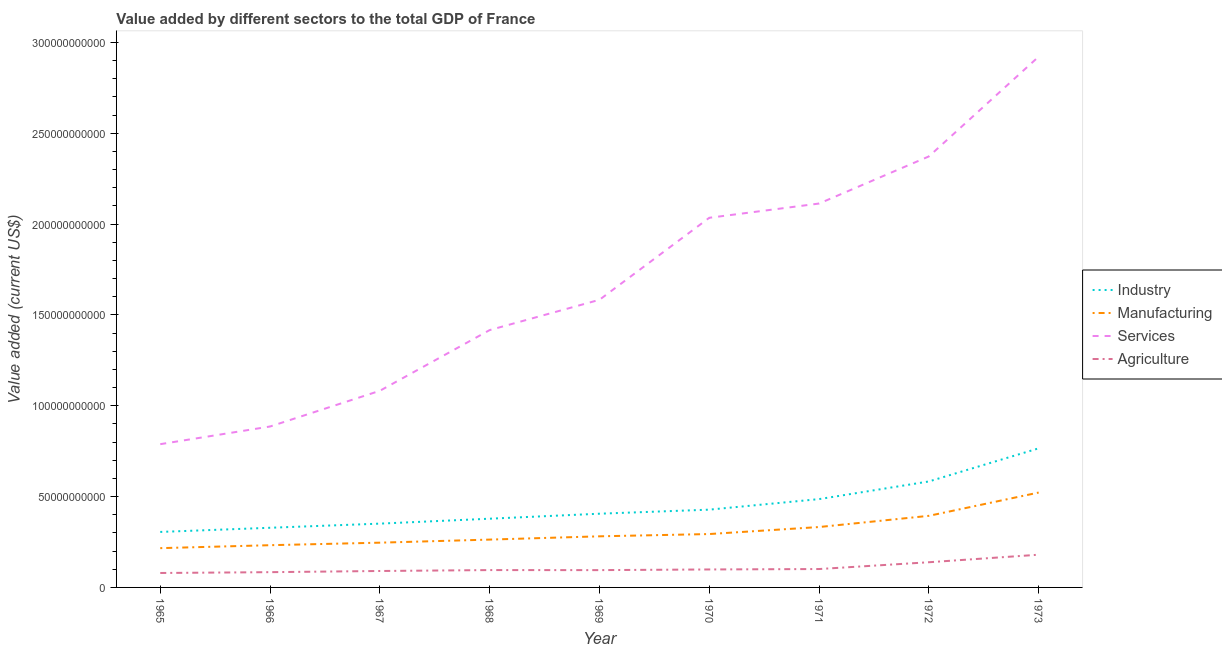Does the line corresponding to value added by industrial sector intersect with the line corresponding to value added by services sector?
Ensure brevity in your answer.  No. Is the number of lines equal to the number of legend labels?
Ensure brevity in your answer.  Yes. What is the value added by manufacturing sector in 1965?
Offer a very short reply. 2.16e+1. Across all years, what is the maximum value added by services sector?
Offer a terse response. 2.92e+11. Across all years, what is the minimum value added by services sector?
Make the answer very short. 7.88e+1. In which year was the value added by services sector maximum?
Ensure brevity in your answer.  1973. In which year was the value added by industrial sector minimum?
Provide a short and direct response. 1965. What is the total value added by services sector in the graph?
Your answer should be compact. 1.52e+12. What is the difference between the value added by industrial sector in 1971 and that in 1972?
Offer a terse response. -9.72e+09. What is the difference between the value added by manufacturing sector in 1972 and the value added by services sector in 1968?
Give a very brief answer. -1.02e+11. What is the average value added by agricultural sector per year?
Your answer should be very brief. 1.07e+1. In the year 1967, what is the difference between the value added by services sector and value added by manufacturing sector?
Your answer should be very brief. 8.36e+1. What is the ratio of the value added by services sector in 1969 to that in 1970?
Your answer should be compact. 0.78. Is the value added by services sector in 1965 less than that in 1971?
Provide a succinct answer. Yes. Is the difference between the value added by services sector in 1965 and 1972 greater than the difference between the value added by agricultural sector in 1965 and 1972?
Make the answer very short. No. What is the difference between the highest and the second highest value added by agricultural sector?
Keep it short and to the point. 4.15e+09. What is the difference between the highest and the lowest value added by agricultural sector?
Provide a succinct answer. 1.01e+1. In how many years, is the value added by services sector greater than the average value added by services sector taken over all years?
Your response must be concise. 4. Is it the case that in every year, the sum of the value added by services sector and value added by manufacturing sector is greater than the sum of value added by industrial sector and value added by agricultural sector?
Give a very brief answer. Yes. Does the value added by industrial sector monotonically increase over the years?
Offer a terse response. Yes. Is the value added by manufacturing sector strictly greater than the value added by agricultural sector over the years?
Provide a succinct answer. Yes. How many lines are there?
Ensure brevity in your answer.  4. Are the values on the major ticks of Y-axis written in scientific E-notation?
Offer a very short reply. No. Does the graph contain any zero values?
Provide a succinct answer. No. Does the graph contain grids?
Your answer should be compact. No. What is the title of the graph?
Your answer should be very brief. Value added by different sectors to the total GDP of France. What is the label or title of the X-axis?
Your answer should be very brief. Year. What is the label or title of the Y-axis?
Your response must be concise. Value added (current US$). What is the Value added (current US$) of Industry in 1965?
Give a very brief answer. 3.05e+1. What is the Value added (current US$) of Manufacturing in 1965?
Make the answer very short. 2.16e+1. What is the Value added (current US$) of Services in 1965?
Keep it short and to the point. 7.88e+1. What is the Value added (current US$) of Agriculture in 1965?
Provide a succinct answer. 7.95e+09. What is the Value added (current US$) in Industry in 1966?
Offer a terse response. 3.28e+1. What is the Value added (current US$) in Manufacturing in 1966?
Offer a very short reply. 2.32e+1. What is the Value added (current US$) in Services in 1966?
Provide a succinct answer. 8.86e+1. What is the Value added (current US$) of Agriculture in 1966?
Ensure brevity in your answer.  8.40e+09. What is the Value added (current US$) in Industry in 1967?
Offer a very short reply. 3.51e+1. What is the Value added (current US$) in Manufacturing in 1967?
Your answer should be compact. 2.46e+1. What is the Value added (current US$) in Services in 1967?
Ensure brevity in your answer.  1.08e+11. What is the Value added (current US$) of Agriculture in 1967?
Provide a succinct answer. 9.05e+09. What is the Value added (current US$) of Industry in 1968?
Keep it short and to the point. 3.78e+1. What is the Value added (current US$) of Manufacturing in 1968?
Make the answer very short. 2.63e+1. What is the Value added (current US$) of Services in 1968?
Your response must be concise. 1.42e+11. What is the Value added (current US$) of Agriculture in 1968?
Offer a terse response. 9.55e+09. What is the Value added (current US$) in Industry in 1969?
Keep it short and to the point. 4.06e+1. What is the Value added (current US$) in Manufacturing in 1969?
Provide a short and direct response. 2.81e+1. What is the Value added (current US$) of Services in 1969?
Provide a succinct answer. 1.58e+11. What is the Value added (current US$) in Agriculture in 1969?
Your response must be concise. 9.52e+09. What is the Value added (current US$) in Industry in 1970?
Offer a terse response. 4.28e+1. What is the Value added (current US$) of Manufacturing in 1970?
Provide a short and direct response. 2.94e+1. What is the Value added (current US$) of Services in 1970?
Give a very brief answer. 2.03e+11. What is the Value added (current US$) in Agriculture in 1970?
Your response must be concise. 9.89e+09. What is the Value added (current US$) in Industry in 1971?
Your answer should be compact. 4.86e+1. What is the Value added (current US$) of Manufacturing in 1971?
Provide a succinct answer. 3.32e+1. What is the Value added (current US$) in Services in 1971?
Ensure brevity in your answer.  2.11e+11. What is the Value added (current US$) in Agriculture in 1971?
Ensure brevity in your answer.  1.01e+1. What is the Value added (current US$) of Industry in 1972?
Provide a short and direct response. 5.83e+1. What is the Value added (current US$) in Manufacturing in 1972?
Your answer should be compact. 3.94e+1. What is the Value added (current US$) of Services in 1972?
Keep it short and to the point. 2.37e+11. What is the Value added (current US$) in Agriculture in 1972?
Offer a very short reply. 1.39e+1. What is the Value added (current US$) of Industry in 1973?
Keep it short and to the point. 7.65e+1. What is the Value added (current US$) of Manufacturing in 1973?
Offer a terse response. 5.22e+1. What is the Value added (current US$) of Services in 1973?
Your response must be concise. 2.92e+11. What is the Value added (current US$) of Agriculture in 1973?
Your answer should be compact. 1.80e+1. Across all years, what is the maximum Value added (current US$) in Industry?
Keep it short and to the point. 7.65e+1. Across all years, what is the maximum Value added (current US$) of Manufacturing?
Give a very brief answer. 5.22e+1. Across all years, what is the maximum Value added (current US$) in Services?
Your response must be concise. 2.92e+11. Across all years, what is the maximum Value added (current US$) of Agriculture?
Your response must be concise. 1.80e+1. Across all years, what is the minimum Value added (current US$) of Industry?
Offer a terse response. 3.05e+1. Across all years, what is the minimum Value added (current US$) in Manufacturing?
Offer a very short reply. 2.16e+1. Across all years, what is the minimum Value added (current US$) of Services?
Provide a short and direct response. 7.88e+1. Across all years, what is the minimum Value added (current US$) in Agriculture?
Make the answer very short. 7.95e+09. What is the total Value added (current US$) in Industry in the graph?
Keep it short and to the point. 4.03e+11. What is the total Value added (current US$) in Manufacturing in the graph?
Offer a terse response. 2.78e+11. What is the total Value added (current US$) in Services in the graph?
Offer a terse response. 1.52e+12. What is the total Value added (current US$) of Agriculture in the graph?
Give a very brief answer. 9.63e+1. What is the difference between the Value added (current US$) in Industry in 1965 and that in 1966?
Keep it short and to the point. -2.29e+09. What is the difference between the Value added (current US$) in Manufacturing in 1965 and that in 1966?
Your response must be concise. -1.62e+09. What is the difference between the Value added (current US$) in Services in 1965 and that in 1966?
Your answer should be very brief. -9.73e+09. What is the difference between the Value added (current US$) of Agriculture in 1965 and that in 1966?
Your response must be concise. -4.53e+08. What is the difference between the Value added (current US$) of Industry in 1965 and that in 1967?
Ensure brevity in your answer.  -4.57e+09. What is the difference between the Value added (current US$) in Manufacturing in 1965 and that in 1967?
Make the answer very short. -3.01e+09. What is the difference between the Value added (current US$) of Services in 1965 and that in 1967?
Provide a short and direct response. -2.94e+1. What is the difference between the Value added (current US$) of Agriculture in 1965 and that in 1967?
Ensure brevity in your answer.  -1.10e+09. What is the difference between the Value added (current US$) of Industry in 1965 and that in 1968?
Provide a succinct answer. -7.28e+09. What is the difference between the Value added (current US$) of Manufacturing in 1965 and that in 1968?
Provide a short and direct response. -4.71e+09. What is the difference between the Value added (current US$) in Services in 1965 and that in 1968?
Offer a very short reply. -6.28e+1. What is the difference between the Value added (current US$) in Agriculture in 1965 and that in 1968?
Your answer should be very brief. -1.60e+09. What is the difference between the Value added (current US$) in Industry in 1965 and that in 1969?
Your answer should be compact. -1.00e+1. What is the difference between the Value added (current US$) of Manufacturing in 1965 and that in 1969?
Offer a very short reply. -6.51e+09. What is the difference between the Value added (current US$) of Services in 1965 and that in 1969?
Ensure brevity in your answer.  -7.95e+1. What is the difference between the Value added (current US$) in Agriculture in 1965 and that in 1969?
Your answer should be compact. -1.58e+09. What is the difference between the Value added (current US$) in Industry in 1965 and that in 1970?
Make the answer very short. -1.23e+1. What is the difference between the Value added (current US$) in Manufacturing in 1965 and that in 1970?
Offer a very short reply. -7.76e+09. What is the difference between the Value added (current US$) of Services in 1965 and that in 1970?
Provide a short and direct response. -1.25e+11. What is the difference between the Value added (current US$) in Agriculture in 1965 and that in 1970?
Ensure brevity in your answer.  -1.94e+09. What is the difference between the Value added (current US$) in Industry in 1965 and that in 1971?
Offer a very short reply. -1.81e+1. What is the difference between the Value added (current US$) in Manufacturing in 1965 and that in 1971?
Your answer should be very brief. -1.16e+1. What is the difference between the Value added (current US$) in Services in 1965 and that in 1971?
Offer a terse response. -1.32e+11. What is the difference between the Value added (current US$) in Agriculture in 1965 and that in 1971?
Provide a short and direct response. -2.17e+09. What is the difference between the Value added (current US$) of Industry in 1965 and that in 1972?
Offer a terse response. -2.78e+1. What is the difference between the Value added (current US$) in Manufacturing in 1965 and that in 1972?
Your answer should be very brief. -1.78e+1. What is the difference between the Value added (current US$) of Services in 1965 and that in 1972?
Provide a short and direct response. -1.58e+11. What is the difference between the Value added (current US$) in Agriculture in 1965 and that in 1972?
Give a very brief answer. -5.91e+09. What is the difference between the Value added (current US$) in Industry in 1965 and that in 1973?
Offer a terse response. -4.60e+1. What is the difference between the Value added (current US$) in Manufacturing in 1965 and that in 1973?
Provide a succinct answer. -3.06e+1. What is the difference between the Value added (current US$) in Services in 1965 and that in 1973?
Your answer should be compact. -2.13e+11. What is the difference between the Value added (current US$) in Agriculture in 1965 and that in 1973?
Your answer should be very brief. -1.01e+1. What is the difference between the Value added (current US$) of Industry in 1966 and that in 1967?
Your response must be concise. -2.28e+09. What is the difference between the Value added (current US$) of Manufacturing in 1966 and that in 1967?
Your answer should be very brief. -1.39e+09. What is the difference between the Value added (current US$) in Services in 1966 and that in 1967?
Offer a terse response. -1.97e+1. What is the difference between the Value added (current US$) of Agriculture in 1966 and that in 1967?
Provide a short and direct response. -6.46e+08. What is the difference between the Value added (current US$) of Industry in 1966 and that in 1968?
Your response must be concise. -4.99e+09. What is the difference between the Value added (current US$) of Manufacturing in 1966 and that in 1968?
Your response must be concise. -3.08e+09. What is the difference between the Value added (current US$) of Services in 1966 and that in 1968?
Provide a succinct answer. -5.31e+1. What is the difference between the Value added (current US$) in Agriculture in 1966 and that in 1968?
Ensure brevity in your answer.  -1.15e+09. What is the difference between the Value added (current US$) of Industry in 1966 and that in 1969?
Your answer should be very brief. -7.74e+09. What is the difference between the Value added (current US$) in Manufacturing in 1966 and that in 1969?
Your response must be concise. -4.88e+09. What is the difference between the Value added (current US$) in Services in 1966 and that in 1969?
Your response must be concise. -6.97e+1. What is the difference between the Value added (current US$) of Agriculture in 1966 and that in 1969?
Keep it short and to the point. -1.12e+09. What is the difference between the Value added (current US$) of Industry in 1966 and that in 1970?
Your response must be concise. -9.97e+09. What is the difference between the Value added (current US$) of Manufacturing in 1966 and that in 1970?
Your response must be concise. -6.14e+09. What is the difference between the Value added (current US$) of Services in 1966 and that in 1970?
Ensure brevity in your answer.  -1.15e+11. What is the difference between the Value added (current US$) of Agriculture in 1966 and that in 1970?
Provide a succinct answer. -1.49e+09. What is the difference between the Value added (current US$) in Industry in 1966 and that in 1971?
Provide a succinct answer. -1.58e+1. What is the difference between the Value added (current US$) of Manufacturing in 1966 and that in 1971?
Your answer should be compact. -1.00e+1. What is the difference between the Value added (current US$) of Services in 1966 and that in 1971?
Provide a succinct answer. -1.23e+11. What is the difference between the Value added (current US$) of Agriculture in 1966 and that in 1971?
Offer a terse response. -1.72e+09. What is the difference between the Value added (current US$) of Industry in 1966 and that in 1972?
Offer a terse response. -2.55e+1. What is the difference between the Value added (current US$) of Manufacturing in 1966 and that in 1972?
Offer a very short reply. -1.62e+1. What is the difference between the Value added (current US$) in Services in 1966 and that in 1972?
Keep it short and to the point. -1.49e+11. What is the difference between the Value added (current US$) of Agriculture in 1966 and that in 1972?
Provide a short and direct response. -5.46e+09. What is the difference between the Value added (current US$) of Industry in 1966 and that in 1973?
Make the answer very short. -4.37e+1. What is the difference between the Value added (current US$) of Manufacturing in 1966 and that in 1973?
Offer a very short reply. -2.90e+1. What is the difference between the Value added (current US$) of Services in 1966 and that in 1973?
Give a very brief answer. -2.04e+11. What is the difference between the Value added (current US$) in Agriculture in 1966 and that in 1973?
Ensure brevity in your answer.  -9.61e+09. What is the difference between the Value added (current US$) in Industry in 1967 and that in 1968?
Offer a very short reply. -2.71e+09. What is the difference between the Value added (current US$) of Manufacturing in 1967 and that in 1968?
Provide a succinct answer. -1.69e+09. What is the difference between the Value added (current US$) in Services in 1967 and that in 1968?
Your answer should be compact. -3.34e+1. What is the difference between the Value added (current US$) of Agriculture in 1967 and that in 1968?
Provide a succinct answer. -5.04e+08. What is the difference between the Value added (current US$) of Industry in 1967 and that in 1969?
Your answer should be compact. -5.46e+09. What is the difference between the Value added (current US$) of Manufacturing in 1967 and that in 1969?
Provide a short and direct response. -3.49e+09. What is the difference between the Value added (current US$) in Services in 1967 and that in 1969?
Your answer should be very brief. -5.01e+1. What is the difference between the Value added (current US$) of Agriculture in 1967 and that in 1969?
Your answer should be compact. -4.78e+08. What is the difference between the Value added (current US$) of Industry in 1967 and that in 1970?
Ensure brevity in your answer.  -7.70e+09. What is the difference between the Value added (current US$) in Manufacturing in 1967 and that in 1970?
Make the answer very short. -4.75e+09. What is the difference between the Value added (current US$) of Services in 1967 and that in 1970?
Ensure brevity in your answer.  -9.52e+1. What is the difference between the Value added (current US$) in Agriculture in 1967 and that in 1970?
Offer a very short reply. -8.44e+08. What is the difference between the Value added (current US$) in Industry in 1967 and that in 1971?
Provide a short and direct response. -1.35e+1. What is the difference between the Value added (current US$) of Manufacturing in 1967 and that in 1971?
Your response must be concise. -8.61e+09. What is the difference between the Value added (current US$) of Services in 1967 and that in 1971?
Give a very brief answer. -1.03e+11. What is the difference between the Value added (current US$) in Agriculture in 1967 and that in 1971?
Make the answer very short. -1.08e+09. What is the difference between the Value added (current US$) in Industry in 1967 and that in 1972?
Your answer should be very brief. -2.32e+1. What is the difference between the Value added (current US$) in Manufacturing in 1967 and that in 1972?
Make the answer very short. -1.48e+1. What is the difference between the Value added (current US$) of Services in 1967 and that in 1972?
Offer a very short reply. -1.29e+11. What is the difference between the Value added (current US$) of Agriculture in 1967 and that in 1972?
Your answer should be compact. -4.81e+09. What is the difference between the Value added (current US$) in Industry in 1967 and that in 1973?
Give a very brief answer. -4.14e+1. What is the difference between the Value added (current US$) in Manufacturing in 1967 and that in 1973?
Your answer should be compact. -2.76e+1. What is the difference between the Value added (current US$) in Services in 1967 and that in 1973?
Offer a terse response. -1.84e+11. What is the difference between the Value added (current US$) in Agriculture in 1967 and that in 1973?
Give a very brief answer. -8.96e+09. What is the difference between the Value added (current US$) in Industry in 1968 and that in 1969?
Keep it short and to the point. -2.75e+09. What is the difference between the Value added (current US$) in Manufacturing in 1968 and that in 1969?
Offer a very short reply. -1.80e+09. What is the difference between the Value added (current US$) of Services in 1968 and that in 1969?
Provide a short and direct response. -1.67e+1. What is the difference between the Value added (current US$) in Agriculture in 1968 and that in 1969?
Offer a terse response. 2.57e+07. What is the difference between the Value added (current US$) of Industry in 1968 and that in 1970?
Offer a terse response. -4.98e+09. What is the difference between the Value added (current US$) in Manufacturing in 1968 and that in 1970?
Provide a succinct answer. -3.05e+09. What is the difference between the Value added (current US$) of Services in 1968 and that in 1970?
Provide a short and direct response. -6.18e+1. What is the difference between the Value added (current US$) in Agriculture in 1968 and that in 1970?
Your answer should be compact. -3.40e+08. What is the difference between the Value added (current US$) in Industry in 1968 and that in 1971?
Make the answer very short. -1.08e+1. What is the difference between the Value added (current US$) in Manufacturing in 1968 and that in 1971?
Provide a short and direct response. -6.91e+09. What is the difference between the Value added (current US$) in Services in 1968 and that in 1971?
Keep it short and to the point. -6.96e+1. What is the difference between the Value added (current US$) of Agriculture in 1968 and that in 1971?
Give a very brief answer. -5.72e+08. What is the difference between the Value added (current US$) of Industry in 1968 and that in 1972?
Provide a short and direct response. -2.05e+1. What is the difference between the Value added (current US$) of Manufacturing in 1968 and that in 1972?
Your answer should be compact. -1.31e+1. What is the difference between the Value added (current US$) of Services in 1968 and that in 1972?
Offer a very short reply. -9.56e+1. What is the difference between the Value added (current US$) in Agriculture in 1968 and that in 1972?
Your response must be concise. -4.31e+09. What is the difference between the Value added (current US$) of Industry in 1968 and that in 1973?
Your answer should be very brief. -3.87e+1. What is the difference between the Value added (current US$) of Manufacturing in 1968 and that in 1973?
Keep it short and to the point. -2.59e+1. What is the difference between the Value added (current US$) of Services in 1968 and that in 1973?
Keep it short and to the point. -1.50e+11. What is the difference between the Value added (current US$) in Agriculture in 1968 and that in 1973?
Offer a very short reply. -8.46e+09. What is the difference between the Value added (current US$) in Industry in 1969 and that in 1970?
Provide a succinct answer. -2.23e+09. What is the difference between the Value added (current US$) in Manufacturing in 1969 and that in 1970?
Make the answer very short. -1.25e+09. What is the difference between the Value added (current US$) in Services in 1969 and that in 1970?
Give a very brief answer. -4.51e+1. What is the difference between the Value added (current US$) in Agriculture in 1969 and that in 1970?
Provide a succinct answer. -3.66e+08. What is the difference between the Value added (current US$) of Industry in 1969 and that in 1971?
Your answer should be very brief. -8.03e+09. What is the difference between the Value added (current US$) of Manufacturing in 1969 and that in 1971?
Give a very brief answer. -5.11e+09. What is the difference between the Value added (current US$) of Services in 1969 and that in 1971?
Provide a short and direct response. -5.30e+1. What is the difference between the Value added (current US$) in Agriculture in 1969 and that in 1971?
Offer a terse response. -5.97e+08. What is the difference between the Value added (current US$) of Industry in 1969 and that in 1972?
Provide a succinct answer. -1.77e+1. What is the difference between the Value added (current US$) of Manufacturing in 1969 and that in 1972?
Ensure brevity in your answer.  -1.13e+1. What is the difference between the Value added (current US$) of Services in 1969 and that in 1972?
Make the answer very short. -7.89e+1. What is the difference between the Value added (current US$) of Agriculture in 1969 and that in 1972?
Offer a very short reply. -4.34e+09. What is the difference between the Value added (current US$) in Industry in 1969 and that in 1973?
Keep it short and to the point. -3.60e+1. What is the difference between the Value added (current US$) of Manufacturing in 1969 and that in 1973?
Give a very brief answer. -2.41e+1. What is the difference between the Value added (current US$) in Services in 1969 and that in 1973?
Provide a succinct answer. -1.34e+11. What is the difference between the Value added (current US$) of Agriculture in 1969 and that in 1973?
Provide a short and direct response. -8.48e+09. What is the difference between the Value added (current US$) of Industry in 1970 and that in 1971?
Provide a succinct answer. -5.80e+09. What is the difference between the Value added (current US$) of Manufacturing in 1970 and that in 1971?
Give a very brief answer. -3.86e+09. What is the difference between the Value added (current US$) of Services in 1970 and that in 1971?
Offer a terse response. -7.84e+09. What is the difference between the Value added (current US$) of Agriculture in 1970 and that in 1971?
Your answer should be very brief. -2.32e+08. What is the difference between the Value added (current US$) in Industry in 1970 and that in 1972?
Offer a very short reply. -1.55e+1. What is the difference between the Value added (current US$) in Manufacturing in 1970 and that in 1972?
Your answer should be compact. -1.00e+1. What is the difference between the Value added (current US$) in Services in 1970 and that in 1972?
Make the answer very short. -3.38e+1. What is the difference between the Value added (current US$) of Agriculture in 1970 and that in 1972?
Ensure brevity in your answer.  -3.97e+09. What is the difference between the Value added (current US$) in Industry in 1970 and that in 1973?
Keep it short and to the point. -3.37e+1. What is the difference between the Value added (current US$) of Manufacturing in 1970 and that in 1973?
Ensure brevity in your answer.  -2.28e+1. What is the difference between the Value added (current US$) of Services in 1970 and that in 1973?
Your answer should be very brief. -8.87e+1. What is the difference between the Value added (current US$) in Agriculture in 1970 and that in 1973?
Your response must be concise. -8.12e+09. What is the difference between the Value added (current US$) of Industry in 1971 and that in 1972?
Provide a succinct answer. -9.72e+09. What is the difference between the Value added (current US$) of Manufacturing in 1971 and that in 1972?
Keep it short and to the point. -6.16e+09. What is the difference between the Value added (current US$) of Services in 1971 and that in 1972?
Provide a succinct answer. -2.59e+1. What is the difference between the Value added (current US$) of Agriculture in 1971 and that in 1972?
Your answer should be compact. -3.74e+09. What is the difference between the Value added (current US$) of Industry in 1971 and that in 1973?
Your response must be concise. -2.79e+1. What is the difference between the Value added (current US$) of Manufacturing in 1971 and that in 1973?
Provide a succinct answer. -1.90e+1. What is the difference between the Value added (current US$) in Services in 1971 and that in 1973?
Offer a very short reply. -8.08e+1. What is the difference between the Value added (current US$) in Agriculture in 1971 and that in 1973?
Your answer should be compact. -7.89e+09. What is the difference between the Value added (current US$) of Industry in 1972 and that in 1973?
Provide a succinct answer. -1.82e+1. What is the difference between the Value added (current US$) of Manufacturing in 1972 and that in 1973?
Offer a very short reply. -1.28e+1. What is the difference between the Value added (current US$) in Services in 1972 and that in 1973?
Ensure brevity in your answer.  -5.49e+1. What is the difference between the Value added (current US$) in Agriculture in 1972 and that in 1973?
Ensure brevity in your answer.  -4.15e+09. What is the difference between the Value added (current US$) of Industry in 1965 and the Value added (current US$) of Manufacturing in 1966?
Your answer should be compact. 7.30e+09. What is the difference between the Value added (current US$) in Industry in 1965 and the Value added (current US$) in Services in 1966?
Make the answer very short. -5.80e+1. What is the difference between the Value added (current US$) in Industry in 1965 and the Value added (current US$) in Agriculture in 1966?
Make the answer very short. 2.21e+1. What is the difference between the Value added (current US$) of Manufacturing in 1965 and the Value added (current US$) of Services in 1966?
Make the answer very short. -6.69e+1. What is the difference between the Value added (current US$) of Manufacturing in 1965 and the Value added (current US$) of Agriculture in 1966?
Make the answer very short. 1.32e+1. What is the difference between the Value added (current US$) of Services in 1965 and the Value added (current US$) of Agriculture in 1966?
Provide a succinct answer. 7.04e+1. What is the difference between the Value added (current US$) in Industry in 1965 and the Value added (current US$) in Manufacturing in 1967?
Offer a terse response. 5.91e+09. What is the difference between the Value added (current US$) of Industry in 1965 and the Value added (current US$) of Services in 1967?
Offer a terse response. -7.77e+1. What is the difference between the Value added (current US$) of Industry in 1965 and the Value added (current US$) of Agriculture in 1967?
Keep it short and to the point. 2.15e+1. What is the difference between the Value added (current US$) of Manufacturing in 1965 and the Value added (current US$) of Services in 1967?
Your answer should be very brief. -8.66e+1. What is the difference between the Value added (current US$) in Manufacturing in 1965 and the Value added (current US$) in Agriculture in 1967?
Ensure brevity in your answer.  1.26e+1. What is the difference between the Value added (current US$) in Services in 1965 and the Value added (current US$) in Agriculture in 1967?
Offer a very short reply. 6.98e+1. What is the difference between the Value added (current US$) of Industry in 1965 and the Value added (current US$) of Manufacturing in 1968?
Ensure brevity in your answer.  4.21e+09. What is the difference between the Value added (current US$) of Industry in 1965 and the Value added (current US$) of Services in 1968?
Provide a succinct answer. -1.11e+11. What is the difference between the Value added (current US$) in Industry in 1965 and the Value added (current US$) in Agriculture in 1968?
Provide a short and direct response. 2.10e+1. What is the difference between the Value added (current US$) in Manufacturing in 1965 and the Value added (current US$) in Services in 1968?
Give a very brief answer. -1.20e+11. What is the difference between the Value added (current US$) of Manufacturing in 1965 and the Value added (current US$) of Agriculture in 1968?
Give a very brief answer. 1.21e+1. What is the difference between the Value added (current US$) of Services in 1965 and the Value added (current US$) of Agriculture in 1968?
Keep it short and to the point. 6.93e+1. What is the difference between the Value added (current US$) in Industry in 1965 and the Value added (current US$) in Manufacturing in 1969?
Provide a short and direct response. 2.41e+09. What is the difference between the Value added (current US$) of Industry in 1965 and the Value added (current US$) of Services in 1969?
Offer a very short reply. -1.28e+11. What is the difference between the Value added (current US$) of Industry in 1965 and the Value added (current US$) of Agriculture in 1969?
Provide a succinct answer. 2.10e+1. What is the difference between the Value added (current US$) in Manufacturing in 1965 and the Value added (current US$) in Services in 1969?
Offer a very short reply. -1.37e+11. What is the difference between the Value added (current US$) in Manufacturing in 1965 and the Value added (current US$) in Agriculture in 1969?
Keep it short and to the point. 1.21e+1. What is the difference between the Value added (current US$) in Services in 1965 and the Value added (current US$) in Agriculture in 1969?
Make the answer very short. 6.93e+1. What is the difference between the Value added (current US$) of Industry in 1965 and the Value added (current US$) of Manufacturing in 1970?
Keep it short and to the point. 1.16e+09. What is the difference between the Value added (current US$) of Industry in 1965 and the Value added (current US$) of Services in 1970?
Ensure brevity in your answer.  -1.73e+11. What is the difference between the Value added (current US$) of Industry in 1965 and the Value added (current US$) of Agriculture in 1970?
Offer a very short reply. 2.07e+1. What is the difference between the Value added (current US$) in Manufacturing in 1965 and the Value added (current US$) in Services in 1970?
Offer a terse response. -1.82e+11. What is the difference between the Value added (current US$) in Manufacturing in 1965 and the Value added (current US$) in Agriculture in 1970?
Offer a terse response. 1.17e+1. What is the difference between the Value added (current US$) of Services in 1965 and the Value added (current US$) of Agriculture in 1970?
Offer a terse response. 6.90e+1. What is the difference between the Value added (current US$) in Industry in 1965 and the Value added (current US$) in Manufacturing in 1971?
Offer a terse response. -2.70e+09. What is the difference between the Value added (current US$) of Industry in 1965 and the Value added (current US$) of Services in 1971?
Provide a succinct answer. -1.81e+11. What is the difference between the Value added (current US$) of Industry in 1965 and the Value added (current US$) of Agriculture in 1971?
Make the answer very short. 2.04e+1. What is the difference between the Value added (current US$) of Manufacturing in 1965 and the Value added (current US$) of Services in 1971?
Give a very brief answer. -1.90e+11. What is the difference between the Value added (current US$) in Manufacturing in 1965 and the Value added (current US$) in Agriculture in 1971?
Ensure brevity in your answer.  1.15e+1. What is the difference between the Value added (current US$) of Services in 1965 and the Value added (current US$) of Agriculture in 1971?
Ensure brevity in your answer.  6.87e+1. What is the difference between the Value added (current US$) of Industry in 1965 and the Value added (current US$) of Manufacturing in 1972?
Give a very brief answer. -8.86e+09. What is the difference between the Value added (current US$) of Industry in 1965 and the Value added (current US$) of Services in 1972?
Your answer should be very brief. -2.07e+11. What is the difference between the Value added (current US$) in Industry in 1965 and the Value added (current US$) in Agriculture in 1972?
Your response must be concise. 1.67e+1. What is the difference between the Value added (current US$) in Manufacturing in 1965 and the Value added (current US$) in Services in 1972?
Provide a succinct answer. -2.16e+11. What is the difference between the Value added (current US$) of Manufacturing in 1965 and the Value added (current US$) of Agriculture in 1972?
Your response must be concise. 7.76e+09. What is the difference between the Value added (current US$) of Services in 1965 and the Value added (current US$) of Agriculture in 1972?
Give a very brief answer. 6.50e+1. What is the difference between the Value added (current US$) in Industry in 1965 and the Value added (current US$) in Manufacturing in 1973?
Offer a terse response. -2.17e+1. What is the difference between the Value added (current US$) of Industry in 1965 and the Value added (current US$) of Services in 1973?
Offer a terse response. -2.62e+11. What is the difference between the Value added (current US$) of Industry in 1965 and the Value added (current US$) of Agriculture in 1973?
Your answer should be compact. 1.25e+1. What is the difference between the Value added (current US$) in Manufacturing in 1965 and the Value added (current US$) in Services in 1973?
Provide a short and direct response. -2.71e+11. What is the difference between the Value added (current US$) of Manufacturing in 1965 and the Value added (current US$) of Agriculture in 1973?
Give a very brief answer. 3.61e+09. What is the difference between the Value added (current US$) in Services in 1965 and the Value added (current US$) in Agriculture in 1973?
Your response must be concise. 6.08e+1. What is the difference between the Value added (current US$) of Industry in 1966 and the Value added (current US$) of Manufacturing in 1967?
Offer a terse response. 8.20e+09. What is the difference between the Value added (current US$) in Industry in 1966 and the Value added (current US$) in Services in 1967?
Your answer should be very brief. -7.54e+1. What is the difference between the Value added (current US$) in Industry in 1966 and the Value added (current US$) in Agriculture in 1967?
Your answer should be very brief. 2.38e+1. What is the difference between the Value added (current US$) of Manufacturing in 1966 and the Value added (current US$) of Services in 1967?
Make the answer very short. -8.50e+1. What is the difference between the Value added (current US$) in Manufacturing in 1966 and the Value added (current US$) in Agriculture in 1967?
Keep it short and to the point. 1.42e+1. What is the difference between the Value added (current US$) in Services in 1966 and the Value added (current US$) in Agriculture in 1967?
Provide a succinct answer. 7.95e+1. What is the difference between the Value added (current US$) of Industry in 1966 and the Value added (current US$) of Manufacturing in 1968?
Your answer should be very brief. 6.51e+09. What is the difference between the Value added (current US$) of Industry in 1966 and the Value added (current US$) of Services in 1968?
Offer a terse response. -1.09e+11. What is the difference between the Value added (current US$) in Industry in 1966 and the Value added (current US$) in Agriculture in 1968?
Offer a very short reply. 2.33e+1. What is the difference between the Value added (current US$) in Manufacturing in 1966 and the Value added (current US$) in Services in 1968?
Offer a very short reply. -1.18e+11. What is the difference between the Value added (current US$) in Manufacturing in 1966 and the Value added (current US$) in Agriculture in 1968?
Keep it short and to the point. 1.37e+1. What is the difference between the Value added (current US$) in Services in 1966 and the Value added (current US$) in Agriculture in 1968?
Keep it short and to the point. 7.90e+1. What is the difference between the Value added (current US$) in Industry in 1966 and the Value added (current US$) in Manufacturing in 1969?
Provide a succinct answer. 4.71e+09. What is the difference between the Value added (current US$) of Industry in 1966 and the Value added (current US$) of Services in 1969?
Give a very brief answer. -1.25e+11. What is the difference between the Value added (current US$) of Industry in 1966 and the Value added (current US$) of Agriculture in 1969?
Give a very brief answer. 2.33e+1. What is the difference between the Value added (current US$) in Manufacturing in 1966 and the Value added (current US$) in Services in 1969?
Your answer should be very brief. -1.35e+11. What is the difference between the Value added (current US$) in Manufacturing in 1966 and the Value added (current US$) in Agriculture in 1969?
Keep it short and to the point. 1.37e+1. What is the difference between the Value added (current US$) of Services in 1966 and the Value added (current US$) of Agriculture in 1969?
Provide a succinct answer. 7.90e+1. What is the difference between the Value added (current US$) of Industry in 1966 and the Value added (current US$) of Manufacturing in 1970?
Your response must be concise. 3.46e+09. What is the difference between the Value added (current US$) in Industry in 1966 and the Value added (current US$) in Services in 1970?
Offer a terse response. -1.71e+11. What is the difference between the Value added (current US$) in Industry in 1966 and the Value added (current US$) in Agriculture in 1970?
Provide a short and direct response. 2.29e+1. What is the difference between the Value added (current US$) in Manufacturing in 1966 and the Value added (current US$) in Services in 1970?
Provide a succinct answer. -1.80e+11. What is the difference between the Value added (current US$) in Manufacturing in 1966 and the Value added (current US$) in Agriculture in 1970?
Provide a succinct answer. 1.34e+1. What is the difference between the Value added (current US$) of Services in 1966 and the Value added (current US$) of Agriculture in 1970?
Offer a terse response. 7.87e+1. What is the difference between the Value added (current US$) in Industry in 1966 and the Value added (current US$) in Manufacturing in 1971?
Your answer should be compact. -4.04e+08. What is the difference between the Value added (current US$) of Industry in 1966 and the Value added (current US$) of Services in 1971?
Your answer should be very brief. -1.78e+11. What is the difference between the Value added (current US$) in Industry in 1966 and the Value added (current US$) in Agriculture in 1971?
Make the answer very short. 2.27e+1. What is the difference between the Value added (current US$) in Manufacturing in 1966 and the Value added (current US$) in Services in 1971?
Your response must be concise. -1.88e+11. What is the difference between the Value added (current US$) of Manufacturing in 1966 and the Value added (current US$) of Agriculture in 1971?
Your answer should be very brief. 1.31e+1. What is the difference between the Value added (current US$) of Services in 1966 and the Value added (current US$) of Agriculture in 1971?
Make the answer very short. 7.84e+1. What is the difference between the Value added (current US$) of Industry in 1966 and the Value added (current US$) of Manufacturing in 1972?
Make the answer very short. -6.57e+09. What is the difference between the Value added (current US$) in Industry in 1966 and the Value added (current US$) in Services in 1972?
Provide a short and direct response. -2.04e+11. What is the difference between the Value added (current US$) in Industry in 1966 and the Value added (current US$) in Agriculture in 1972?
Offer a terse response. 1.90e+1. What is the difference between the Value added (current US$) in Manufacturing in 1966 and the Value added (current US$) in Services in 1972?
Provide a short and direct response. -2.14e+11. What is the difference between the Value added (current US$) in Manufacturing in 1966 and the Value added (current US$) in Agriculture in 1972?
Offer a very short reply. 9.38e+09. What is the difference between the Value added (current US$) of Services in 1966 and the Value added (current US$) of Agriculture in 1972?
Provide a short and direct response. 7.47e+1. What is the difference between the Value added (current US$) in Industry in 1966 and the Value added (current US$) in Manufacturing in 1973?
Give a very brief answer. -1.94e+1. What is the difference between the Value added (current US$) of Industry in 1966 and the Value added (current US$) of Services in 1973?
Your answer should be compact. -2.59e+11. What is the difference between the Value added (current US$) in Industry in 1966 and the Value added (current US$) in Agriculture in 1973?
Keep it short and to the point. 1.48e+1. What is the difference between the Value added (current US$) of Manufacturing in 1966 and the Value added (current US$) of Services in 1973?
Your answer should be very brief. -2.69e+11. What is the difference between the Value added (current US$) in Manufacturing in 1966 and the Value added (current US$) in Agriculture in 1973?
Keep it short and to the point. 5.24e+09. What is the difference between the Value added (current US$) in Services in 1966 and the Value added (current US$) in Agriculture in 1973?
Your answer should be compact. 7.06e+1. What is the difference between the Value added (current US$) in Industry in 1967 and the Value added (current US$) in Manufacturing in 1968?
Make the answer very short. 8.79e+09. What is the difference between the Value added (current US$) in Industry in 1967 and the Value added (current US$) in Services in 1968?
Provide a succinct answer. -1.07e+11. What is the difference between the Value added (current US$) in Industry in 1967 and the Value added (current US$) in Agriculture in 1968?
Give a very brief answer. 2.56e+1. What is the difference between the Value added (current US$) in Manufacturing in 1967 and the Value added (current US$) in Services in 1968?
Your answer should be very brief. -1.17e+11. What is the difference between the Value added (current US$) of Manufacturing in 1967 and the Value added (current US$) of Agriculture in 1968?
Your response must be concise. 1.51e+1. What is the difference between the Value added (current US$) of Services in 1967 and the Value added (current US$) of Agriculture in 1968?
Keep it short and to the point. 9.87e+1. What is the difference between the Value added (current US$) of Industry in 1967 and the Value added (current US$) of Manufacturing in 1969?
Make the answer very short. 6.99e+09. What is the difference between the Value added (current US$) of Industry in 1967 and the Value added (current US$) of Services in 1969?
Keep it short and to the point. -1.23e+11. What is the difference between the Value added (current US$) in Industry in 1967 and the Value added (current US$) in Agriculture in 1969?
Your answer should be very brief. 2.56e+1. What is the difference between the Value added (current US$) of Manufacturing in 1967 and the Value added (current US$) of Services in 1969?
Make the answer very short. -1.34e+11. What is the difference between the Value added (current US$) of Manufacturing in 1967 and the Value added (current US$) of Agriculture in 1969?
Provide a succinct answer. 1.51e+1. What is the difference between the Value added (current US$) in Services in 1967 and the Value added (current US$) in Agriculture in 1969?
Keep it short and to the point. 9.87e+1. What is the difference between the Value added (current US$) of Industry in 1967 and the Value added (current US$) of Manufacturing in 1970?
Your response must be concise. 5.73e+09. What is the difference between the Value added (current US$) in Industry in 1967 and the Value added (current US$) in Services in 1970?
Provide a succinct answer. -1.68e+11. What is the difference between the Value added (current US$) of Industry in 1967 and the Value added (current US$) of Agriculture in 1970?
Offer a terse response. 2.52e+1. What is the difference between the Value added (current US$) in Manufacturing in 1967 and the Value added (current US$) in Services in 1970?
Provide a succinct answer. -1.79e+11. What is the difference between the Value added (current US$) of Manufacturing in 1967 and the Value added (current US$) of Agriculture in 1970?
Make the answer very short. 1.47e+1. What is the difference between the Value added (current US$) in Services in 1967 and the Value added (current US$) in Agriculture in 1970?
Make the answer very short. 9.83e+1. What is the difference between the Value added (current US$) of Industry in 1967 and the Value added (current US$) of Manufacturing in 1971?
Ensure brevity in your answer.  1.87e+09. What is the difference between the Value added (current US$) in Industry in 1967 and the Value added (current US$) in Services in 1971?
Offer a terse response. -1.76e+11. What is the difference between the Value added (current US$) of Industry in 1967 and the Value added (current US$) of Agriculture in 1971?
Provide a succinct answer. 2.50e+1. What is the difference between the Value added (current US$) of Manufacturing in 1967 and the Value added (current US$) of Services in 1971?
Provide a succinct answer. -1.87e+11. What is the difference between the Value added (current US$) of Manufacturing in 1967 and the Value added (current US$) of Agriculture in 1971?
Keep it short and to the point. 1.45e+1. What is the difference between the Value added (current US$) in Services in 1967 and the Value added (current US$) in Agriculture in 1971?
Offer a very short reply. 9.81e+1. What is the difference between the Value added (current US$) of Industry in 1967 and the Value added (current US$) of Manufacturing in 1972?
Provide a short and direct response. -4.29e+09. What is the difference between the Value added (current US$) in Industry in 1967 and the Value added (current US$) in Services in 1972?
Your answer should be compact. -2.02e+11. What is the difference between the Value added (current US$) of Industry in 1967 and the Value added (current US$) of Agriculture in 1972?
Keep it short and to the point. 2.13e+1. What is the difference between the Value added (current US$) in Manufacturing in 1967 and the Value added (current US$) in Services in 1972?
Keep it short and to the point. -2.13e+11. What is the difference between the Value added (current US$) in Manufacturing in 1967 and the Value added (current US$) in Agriculture in 1972?
Provide a succinct answer. 1.08e+1. What is the difference between the Value added (current US$) in Services in 1967 and the Value added (current US$) in Agriculture in 1972?
Your response must be concise. 9.44e+1. What is the difference between the Value added (current US$) of Industry in 1967 and the Value added (current US$) of Manufacturing in 1973?
Offer a very short reply. -1.71e+1. What is the difference between the Value added (current US$) of Industry in 1967 and the Value added (current US$) of Services in 1973?
Offer a very short reply. -2.57e+11. What is the difference between the Value added (current US$) in Industry in 1967 and the Value added (current US$) in Agriculture in 1973?
Offer a very short reply. 1.71e+1. What is the difference between the Value added (current US$) in Manufacturing in 1967 and the Value added (current US$) in Services in 1973?
Provide a succinct answer. -2.67e+11. What is the difference between the Value added (current US$) of Manufacturing in 1967 and the Value added (current US$) of Agriculture in 1973?
Offer a very short reply. 6.63e+09. What is the difference between the Value added (current US$) of Services in 1967 and the Value added (current US$) of Agriculture in 1973?
Give a very brief answer. 9.02e+1. What is the difference between the Value added (current US$) in Industry in 1968 and the Value added (current US$) in Manufacturing in 1969?
Offer a terse response. 9.70e+09. What is the difference between the Value added (current US$) of Industry in 1968 and the Value added (current US$) of Services in 1969?
Offer a very short reply. -1.20e+11. What is the difference between the Value added (current US$) of Industry in 1968 and the Value added (current US$) of Agriculture in 1969?
Offer a terse response. 2.83e+1. What is the difference between the Value added (current US$) in Manufacturing in 1968 and the Value added (current US$) in Services in 1969?
Give a very brief answer. -1.32e+11. What is the difference between the Value added (current US$) of Manufacturing in 1968 and the Value added (current US$) of Agriculture in 1969?
Offer a terse response. 1.68e+1. What is the difference between the Value added (current US$) of Services in 1968 and the Value added (current US$) of Agriculture in 1969?
Your answer should be very brief. 1.32e+11. What is the difference between the Value added (current US$) of Industry in 1968 and the Value added (current US$) of Manufacturing in 1970?
Make the answer very short. 8.45e+09. What is the difference between the Value added (current US$) of Industry in 1968 and the Value added (current US$) of Services in 1970?
Make the answer very short. -1.66e+11. What is the difference between the Value added (current US$) of Industry in 1968 and the Value added (current US$) of Agriculture in 1970?
Provide a succinct answer. 2.79e+1. What is the difference between the Value added (current US$) in Manufacturing in 1968 and the Value added (current US$) in Services in 1970?
Provide a short and direct response. -1.77e+11. What is the difference between the Value added (current US$) in Manufacturing in 1968 and the Value added (current US$) in Agriculture in 1970?
Give a very brief answer. 1.64e+1. What is the difference between the Value added (current US$) of Services in 1968 and the Value added (current US$) of Agriculture in 1970?
Ensure brevity in your answer.  1.32e+11. What is the difference between the Value added (current US$) of Industry in 1968 and the Value added (current US$) of Manufacturing in 1971?
Your answer should be compact. 4.58e+09. What is the difference between the Value added (current US$) of Industry in 1968 and the Value added (current US$) of Services in 1971?
Ensure brevity in your answer.  -1.73e+11. What is the difference between the Value added (current US$) in Industry in 1968 and the Value added (current US$) in Agriculture in 1971?
Make the answer very short. 2.77e+1. What is the difference between the Value added (current US$) of Manufacturing in 1968 and the Value added (current US$) of Services in 1971?
Your answer should be compact. -1.85e+11. What is the difference between the Value added (current US$) of Manufacturing in 1968 and the Value added (current US$) of Agriculture in 1971?
Your response must be concise. 1.62e+1. What is the difference between the Value added (current US$) of Services in 1968 and the Value added (current US$) of Agriculture in 1971?
Offer a terse response. 1.32e+11. What is the difference between the Value added (current US$) in Industry in 1968 and the Value added (current US$) in Manufacturing in 1972?
Offer a terse response. -1.58e+09. What is the difference between the Value added (current US$) in Industry in 1968 and the Value added (current US$) in Services in 1972?
Give a very brief answer. -1.99e+11. What is the difference between the Value added (current US$) of Industry in 1968 and the Value added (current US$) of Agriculture in 1972?
Offer a very short reply. 2.40e+1. What is the difference between the Value added (current US$) of Manufacturing in 1968 and the Value added (current US$) of Services in 1972?
Your answer should be compact. -2.11e+11. What is the difference between the Value added (current US$) of Manufacturing in 1968 and the Value added (current US$) of Agriculture in 1972?
Your answer should be compact. 1.25e+1. What is the difference between the Value added (current US$) in Services in 1968 and the Value added (current US$) in Agriculture in 1972?
Your response must be concise. 1.28e+11. What is the difference between the Value added (current US$) in Industry in 1968 and the Value added (current US$) in Manufacturing in 1973?
Provide a succinct answer. -1.44e+1. What is the difference between the Value added (current US$) in Industry in 1968 and the Value added (current US$) in Services in 1973?
Ensure brevity in your answer.  -2.54e+11. What is the difference between the Value added (current US$) in Industry in 1968 and the Value added (current US$) in Agriculture in 1973?
Offer a terse response. 1.98e+1. What is the difference between the Value added (current US$) of Manufacturing in 1968 and the Value added (current US$) of Services in 1973?
Make the answer very short. -2.66e+11. What is the difference between the Value added (current US$) of Manufacturing in 1968 and the Value added (current US$) of Agriculture in 1973?
Your answer should be very brief. 8.32e+09. What is the difference between the Value added (current US$) of Services in 1968 and the Value added (current US$) of Agriculture in 1973?
Provide a succinct answer. 1.24e+11. What is the difference between the Value added (current US$) of Industry in 1969 and the Value added (current US$) of Manufacturing in 1970?
Provide a short and direct response. 1.12e+1. What is the difference between the Value added (current US$) in Industry in 1969 and the Value added (current US$) in Services in 1970?
Ensure brevity in your answer.  -1.63e+11. What is the difference between the Value added (current US$) in Industry in 1969 and the Value added (current US$) in Agriculture in 1970?
Ensure brevity in your answer.  3.07e+1. What is the difference between the Value added (current US$) of Manufacturing in 1969 and the Value added (current US$) of Services in 1970?
Provide a succinct answer. -1.75e+11. What is the difference between the Value added (current US$) in Manufacturing in 1969 and the Value added (current US$) in Agriculture in 1970?
Your answer should be compact. 1.82e+1. What is the difference between the Value added (current US$) of Services in 1969 and the Value added (current US$) of Agriculture in 1970?
Offer a very short reply. 1.48e+11. What is the difference between the Value added (current US$) in Industry in 1969 and the Value added (current US$) in Manufacturing in 1971?
Ensure brevity in your answer.  7.33e+09. What is the difference between the Value added (current US$) in Industry in 1969 and the Value added (current US$) in Services in 1971?
Provide a succinct answer. -1.71e+11. What is the difference between the Value added (current US$) of Industry in 1969 and the Value added (current US$) of Agriculture in 1971?
Provide a short and direct response. 3.05e+1. What is the difference between the Value added (current US$) of Manufacturing in 1969 and the Value added (current US$) of Services in 1971?
Provide a succinct answer. -1.83e+11. What is the difference between the Value added (current US$) of Manufacturing in 1969 and the Value added (current US$) of Agriculture in 1971?
Provide a short and direct response. 1.80e+1. What is the difference between the Value added (current US$) of Services in 1969 and the Value added (current US$) of Agriculture in 1971?
Your answer should be compact. 1.48e+11. What is the difference between the Value added (current US$) in Industry in 1969 and the Value added (current US$) in Manufacturing in 1972?
Keep it short and to the point. 1.17e+09. What is the difference between the Value added (current US$) in Industry in 1969 and the Value added (current US$) in Services in 1972?
Your answer should be very brief. -1.97e+11. What is the difference between the Value added (current US$) of Industry in 1969 and the Value added (current US$) of Agriculture in 1972?
Give a very brief answer. 2.67e+1. What is the difference between the Value added (current US$) in Manufacturing in 1969 and the Value added (current US$) in Services in 1972?
Your answer should be very brief. -2.09e+11. What is the difference between the Value added (current US$) in Manufacturing in 1969 and the Value added (current US$) in Agriculture in 1972?
Your response must be concise. 1.43e+1. What is the difference between the Value added (current US$) of Services in 1969 and the Value added (current US$) of Agriculture in 1972?
Provide a short and direct response. 1.44e+11. What is the difference between the Value added (current US$) in Industry in 1969 and the Value added (current US$) in Manufacturing in 1973?
Give a very brief answer. -1.16e+1. What is the difference between the Value added (current US$) in Industry in 1969 and the Value added (current US$) in Services in 1973?
Keep it short and to the point. -2.52e+11. What is the difference between the Value added (current US$) of Industry in 1969 and the Value added (current US$) of Agriculture in 1973?
Provide a short and direct response. 2.26e+1. What is the difference between the Value added (current US$) of Manufacturing in 1969 and the Value added (current US$) of Services in 1973?
Your answer should be compact. -2.64e+11. What is the difference between the Value added (current US$) in Manufacturing in 1969 and the Value added (current US$) in Agriculture in 1973?
Your response must be concise. 1.01e+1. What is the difference between the Value added (current US$) of Services in 1969 and the Value added (current US$) of Agriculture in 1973?
Your answer should be very brief. 1.40e+11. What is the difference between the Value added (current US$) in Industry in 1970 and the Value added (current US$) in Manufacturing in 1971?
Make the answer very short. 9.57e+09. What is the difference between the Value added (current US$) in Industry in 1970 and the Value added (current US$) in Services in 1971?
Your response must be concise. -1.68e+11. What is the difference between the Value added (current US$) in Industry in 1970 and the Value added (current US$) in Agriculture in 1971?
Provide a succinct answer. 3.27e+1. What is the difference between the Value added (current US$) of Manufacturing in 1970 and the Value added (current US$) of Services in 1971?
Offer a terse response. -1.82e+11. What is the difference between the Value added (current US$) of Manufacturing in 1970 and the Value added (current US$) of Agriculture in 1971?
Provide a succinct answer. 1.93e+1. What is the difference between the Value added (current US$) of Services in 1970 and the Value added (current US$) of Agriculture in 1971?
Your answer should be very brief. 1.93e+11. What is the difference between the Value added (current US$) in Industry in 1970 and the Value added (current US$) in Manufacturing in 1972?
Your answer should be very brief. 3.41e+09. What is the difference between the Value added (current US$) of Industry in 1970 and the Value added (current US$) of Services in 1972?
Provide a short and direct response. -1.94e+11. What is the difference between the Value added (current US$) in Industry in 1970 and the Value added (current US$) in Agriculture in 1972?
Offer a very short reply. 2.89e+1. What is the difference between the Value added (current US$) of Manufacturing in 1970 and the Value added (current US$) of Services in 1972?
Your response must be concise. -2.08e+11. What is the difference between the Value added (current US$) of Manufacturing in 1970 and the Value added (current US$) of Agriculture in 1972?
Your answer should be compact. 1.55e+1. What is the difference between the Value added (current US$) in Services in 1970 and the Value added (current US$) in Agriculture in 1972?
Offer a very short reply. 1.90e+11. What is the difference between the Value added (current US$) in Industry in 1970 and the Value added (current US$) in Manufacturing in 1973?
Your response must be concise. -9.41e+09. What is the difference between the Value added (current US$) in Industry in 1970 and the Value added (current US$) in Services in 1973?
Make the answer very short. -2.49e+11. What is the difference between the Value added (current US$) in Industry in 1970 and the Value added (current US$) in Agriculture in 1973?
Provide a succinct answer. 2.48e+1. What is the difference between the Value added (current US$) in Manufacturing in 1970 and the Value added (current US$) in Services in 1973?
Keep it short and to the point. -2.63e+11. What is the difference between the Value added (current US$) in Manufacturing in 1970 and the Value added (current US$) in Agriculture in 1973?
Ensure brevity in your answer.  1.14e+1. What is the difference between the Value added (current US$) of Services in 1970 and the Value added (current US$) of Agriculture in 1973?
Ensure brevity in your answer.  1.85e+11. What is the difference between the Value added (current US$) in Industry in 1971 and the Value added (current US$) in Manufacturing in 1972?
Keep it short and to the point. 9.20e+09. What is the difference between the Value added (current US$) of Industry in 1971 and the Value added (current US$) of Services in 1972?
Keep it short and to the point. -1.89e+11. What is the difference between the Value added (current US$) in Industry in 1971 and the Value added (current US$) in Agriculture in 1972?
Ensure brevity in your answer.  3.47e+1. What is the difference between the Value added (current US$) of Manufacturing in 1971 and the Value added (current US$) of Services in 1972?
Give a very brief answer. -2.04e+11. What is the difference between the Value added (current US$) of Manufacturing in 1971 and the Value added (current US$) of Agriculture in 1972?
Make the answer very short. 1.94e+1. What is the difference between the Value added (current US$) in Services in 1971 and the Value added (current US$) in Agriculture in 1972?
Offer a terse response. 1.97e+11. What is the difference between the Value added (current US$) of Industry in 1971 and the Value added (current US$) of Manufacturing in 1973?
Your response must be concise. -3.61e+09. What is the difference between the Value added (current US$) of Industry in 1971 and the Value added (current US$) of Services in 1973?
Make the answer very short. -2.44e+11. What is the difference between the Value added (current US$) of Industry in 1971 and the Value added (current US$) of Agriculture in 1973?
Provide a short and direct response. 3.06e+1. What is the difference between the Value added (current US$) in Manufacturing in 1971 and the Value added (current US$) in Services in 1973?
Make the answer very short. -2.59e+11. What is the difference between the Value added (current US$) in Manufacturing in 1971 and the Value added (current US$) in Agriculture in 1973?
Your answer should be compact. 1.52e+1. What is the difference between the Value added (current US$) of Services in 1971 and the Value added (current US$) of Agriculture in 1973?
Keep it short and to the point. 1.93e+11. What is the difference between the Value added (current US$) in Industry in 1972 and the Value added (current US$) in Manufacturing in 1973?
Offer a terse response. 6.10e+09. What is the difference between the Value added (current US$) in Industry in 1972 and the Value added (current US$) in Services in 1973?
Your response must be concise. -2.34e+11. What is the difference between the Value added (current US$) of Industry in 1972 and the Value added (current US$) of Agriculture in 1973?
Your response must be concise. 4.03e+1. What is the difference between the Value added (current US$) of Manufacturing in 1972 and the Value added (current US$) of Services in 1973?
Offer a terse response. -2.53e+11. What is the difference between the Value added (current US$) in Manufacturing in 1972 and the Value added (current US$) in Agriculture in 1973?
Your response must be concise. 2.14e+1. What is the difference between the Value added (current US$) of Services in 1972 and the Value added (current US$) of Agriculture in 1973?
Your answer should be compact. 2.19e+11. What is the average Value added (current US$) of Industry per year?
Ensure brevity in your answer.  4.48e+1. What is the average Value added (current US$) of Manufacturing per year?
Keep it short and to the point. 3.09e+1. What is the average Value added (current US$) of Services per year?
Give a very brief answer. 1.69e+11. What is the average Value added (current US$) of Agriculture per year?
Offer a very short reply. 1.07e+1. In the year 1965, what is the difference between the Value added (current US$) of Industry and Value added (current US$) of Manufacturing?
Ensure brevity in your answer.  8.92e+09. In the year 1965, what is the difference between the Value added (current US$) of Industry and Value added (current US$) of Services?
Ensure brevity in your answer.  -4.83e+1. In the year 1965, what is the difference between the Value added (current US$) in Industry and Value added (current US$) in Agriculture?
Give a very brief answer. 2.26e+1. In the year 1965, what is the difference between the Value added (current US$) of Manufacturing and Value added (current US$) of Services?
Provide a short and direct response. -5.72e+1. In the year 1965, what is the difference between the Value added (current US$) of Manufacturing and Value added (current US$) of Agriculture?
Make the answer very short. 1.37e+1. In the year 1965, what is the difference between the Value added (current US$) of Services and Value added (current US$) of Agriculture?
Ensure brevity in your answer.  7.09e+1. In the year 1966, what is the difference between the Value added (current US$) of Industry and Value added (current US$) of Manufacturing?
Your answer should be very brief. 9.59e+09. In the year 1966, what is the difference between the Value added (current US$) in Industry and Value added (current US$) in Services?
Give a very brief answer. -5.57e+1. In the year 1966, what is the difference between the Value added (current US$) of Industry and Value added (current US$) of Agriculture?
Make the answer very short. 2.44e+1. In the year 1966, what is the difference between the Value added (current US$) of Manufacturing and Value added (current US$) of Services?
Provide a short and direct response. -6.53e+1. In the year 1966, what is the difference between the Value added (current US$) in Manufacturing and Value added (current US$) in Agriculture?
Offer a very short reply. 1.48e+1. In the year 1966, what is the difference between the Value added (current US$) of Services and Value added (current US$) of Agriculture?
Give a very brief answer. 8.02e+1. In the year 1967, what is the difference between the Value added (current US$) in Industry and Value added (current US$) in Manufacturing?
Offer a very short reply. 1.05e+1. In the year 1967, what is the difference between the Value added (current US$) of Industry and Value added (current US$) of Services?
Keep it short and to the point. -7.31e+1. In the year 1967, what is the difference between the Value added (current US$) in Industry and Value added (current US$) in Agriculture?
Provide a short and direct response. 2.61e+1. In the year 1967, what is the difference between the Value added (current US$) in Manufacturing and Value added (current US$) in Services?
Provide a short and direct response. -8.36e+1. In the year 1967, what is the difference between the Value added (current US$) in Manufacturing and Value added (current US$) in Agriculture?
Keep it short and to the point. 1.56e+1. In the year 1967, what is the difference between the Value added (current US$) in Services and Value added (current US$) in Agriculture?
Provide a succinct answer. 9.92e+1. In the year 1968, what is the difference between the Value added (current US$) in Industry and Value added (current US$) in Manufacturing?
Provide a succinct answer. 1.15e+1. In the year 1968, what is the difference between the Value added (current US$) in Industry and Value added (current US$) in Services?
Give a very brief answer. -1.04e+11. In the year 1968, what is the difference between the Value added (current US$) in Industry and Value added (current US$) in Agriculture?
Ensure brevity in your answer.  2.83e+1. In the year 1968, what is the difference between the Value added (current US$) in Manufacturing and Value added (current US$) in Services?
Provide a short and direct response. -1.15e+11. In the year 1968, what is the difference between the Value added (current US$) in Manufacturing and Value added (current US$) in Agriculture?
Keep it short and to the point. 1.68e+1. In the year 1968, what is the difference between the Value added (current US$) of Services and Value added (current US$) of Agriculture?
Keep it short and to the point. 1.32e+11. In the year 1969, what is the difference between the Value added (current US$) in Industry and Value added (current US$) in Manufacturing?
Offer a very short reply. 1.24e+1. In the year 1969, what is the difference between the Value added (current US$) in Industry and Value added (current US$) in Services?
Give a very brief answer. -1.18e+11. In the year 1969, what is the difference between the Value added (current US$) of Industry and Value added (current US$) of Agriculture?
Your answer should be very brief. 3.11e+1. In the year 1969, what is the difference between the Value added (current US$) of Manufacturing and Value added (current US$) of Services?
Your answer should be very brief. -1.30e+11. In the year 1969, what is the difference between the Value added (current US$) of Manufacturing and Value added (current US$) of Agriculture?
Give a very brief answer. 1.86e+1. In the year 1969, what is the difference between the Value added (current US$) in Services and Value added (current US$) in Agriculture?
Keep it short and to the point. 1.49e+11. In the year 1970, what is the difference between the Value added (current US$) in Industry and Value added (current US$) in Manufacturing?
Offer a very short reply. 1.34e+1. In the year 1970, what is the difference between the Value added (current US$) in Industry and Value added (current US$) in Services?
Give a very brief answer. -1.61e+11. In the year 1970, what is the difference between the Value added (current US$) in Industry and Value added (current US$) in Agriculture?
Make the answer very short. 3.29e+1. In the year 1970, what is the difference between the Value added (current US$) in Manufacturing and Value added (current US$) in Services?
Your answer should be very brief. -1.74e+11. In the year 1970, what is the difference between the Value added (current US$) of Manufacturing and Value added (current US$) of Agriculture?
Keep it short and to the point. 1.95e+1. In the year 1970, what is the difference between the Value added (current US$) of Services and Value added (current US$) of Agriculture?
Provide a short and direct response. 1.94e+11. In the year 1971, what is the difference between the Value added (current US$) of Industry and Value added (current US$) of Manufacturing?
Provide a short and direct response. 1.54e+1. In the year 1971, what is the difference between the Value added (current US$) of Industry and Value added (current US$) of Services?
Your answer should be compact. -1.63e+11. In the year 1971, what is the difference between the Value added (current US$) of Industry and Value added (current US$) of Agriculture?
Provide a succinct answer. 3.85e+1. In the year 1971, what is the difference between the Value added (current US$) of Manufacturing and Value added (current US$) of Services?
Provide a succinct answer. -1.78e+11. In the year 1971, what is the difference between the Value added (current US$) in Manufacturing and Value added (current US$) in Agriculture?
Your answer should be compact. 2.31e+1. In the year 1971, what is the difference between the Value added (current US$) in Services and Value added (current US$) in Agriculture?
Provide a short and direct response. 2.01e+11. In the year 1972, what is the difference between the Value added (current US$) in Industry and Value added (current US$) in Manufacturing?
Offer a terse response. 1.89e+1. In the year 1972, what is the difference between the Value added (current US$) in Industry and Value added (current US$) in Services?
Provide a short and direct response. -1.79e+11. In the year 1972, what is the difference between the Value added (current US$) of Industry and Value added (current US$) of Agriculture?
Your response must be concise. 4.45e+1. In the year 1972, what is the difference between the Value added (current US$) of Manufacturing and Value added (current US$) of Services?
Your answer should be very brief. -1.98e+11. In the year 1972, what is the difference between the Value added (current US$) in Manufacturing and Value added (current US$) in Agriculture?
Provide a short and direct response. 2.55e+1. In the year 1972, what is the difference between the Value added (current US$) of Services and Value added (current US$) of Agriculture?
Offer a terse response. 2.23e+11. In the year 1973, what is the difference between the Value added (current US$) in Industry and Value added (current US$) in Manufacturing?
Offer a very short reply. 2.43e+1. In the year 1973, what is the difference between the Value added (current US$) in Industry and Value added (current US$) in Services?
Ensure brevity in your answer.  -2.16e+11. In the year 1973, what is the difference between the Value added (current US$) of Industry and Value added (current US$) of Agriculture?
Provide a short and direct response. 5.85e+1. In the year 1973, what is the difference between the Value added (current US$) of Manufacturing and Value added (current US$) of Services?
Make the answer very short. -2.40e+11. In the year 1973, what is the difference between the Value added (current US$) in Manufacturing and Value added (current US$) in Agriculture?
Your answer should be compact. 3.42e+1. In the year 1973, what is the difference between the Value added (current US$) in Services and Value added (current US$) in Agriculture?
Offer a very short reply. 2.74e+11. What is the ratio of the Value added (current US$) in Industry in 1965 to that in 1966?
Provide a succinct answer. 0.93. What is the ratio of the Value added (current US$) in Manufacturing in 1965 to that in 1966?
Your response must be concise. 0.93. What is the ratio of the Value added (current US$) in Services in 1965 to that in 1966?
Your answer should be compact. 0.89. What is the ratio of the Value added (current US$) in Agriculture in 1965 to that in 1966?
Keep it short and to the point. 0.95. What is the ratio of the Value added (current US$) in Industry in 1965 to that in 1967?
Keep it short and to the point. 0.87. What is the ratio of the Value added (current US$) in Manufacturing in 1965 to that in 1967?
Ensure brevity in your answer.  0.88. What is the ratio of the Value added (current US$) in Services in 1965 to that in 1967?
Offer a terse response. 0.73. What is the ratio of the Value added (current US$) of Agriculture in 1965 to that in 1967?
Offer a very short reply. 0.88. What is the ratio of the Value added (current US$) of Industry in 1965 to that in 1968?
Make the answer very short. 0.81. What is the ratio of the Value added (current US$) in Manufacturing in 1965 to that in 1968?
Keep it short and to the point. 0.82. What is the ratio of the Value added (current US$) in Services in 1965 to that in 1968?
Your response must be concise. 0.56. What is the ratio of the Value added (current US$) in Agriculture in 1965 to that in 1968?
Offer a very short reply. 0.83. What is the ratio of the Value added (current US$) in Industry in 1965 to that in 1969?
Make the answer very short. 0.75. What is the ratio of the Value added (current US$) in Manufacturing in 1965 to that in 1969?
Give a very brief answer. 0.77. What is the ratio of the Value added (current US$) of Services in 1965 to that in 1969?
Keep it short and to the point. 0.5. What is the ratio of the Value added (current US$) in Agriculture in 1965 to that in 1969?
Keep it short and to the point. 0.83. What is the ratio of the Value added (current US$) in Industry in 1965 to that in 1970?
Provide a short and direct response. 0.71. What is the ratio of the Value added (current US$) in Manufacturing in 1965 to that in 1970?
Your response must be concise. 0.74. What is the ratio of the Value added (current US$) of Services in 1965 to that in 1970?
Your answer should be compact. 0.39. What is the ratio of the Value added (current US$) in Agriculture in 1965 to that in 1970?
Provide a short and direct response. 0.8. What is the ratio of the Value added (current US$) of Industry in 1965 to that in 1971?
Your response must be concise. 0.63. What is the ratio of the Value added (current US$) of Manufacturing in 1965 to that in 1971?
Your response must be concise. 0.65. What is the ratio of the Value added (current US$) in Services in 1965 to that in 1971?
Your answer should be very brief. 0.37. What is the ratio of the Value added (current US$) of Agriculture in 1965 to that in 1971?
Offer a very short reply. 0.79. What is the ratio of the Value added (current US$) of Industry in 1965 to that in 1972?
Offer a terse response. 0.52. What is the ratio of the Value added (current US$) in Manufacturing in 1965 to that in 1972?
Your response must be concise. 0.55. What is the ratio of the Value added (current US$) in Services in 1965 to that in 1972?
Ensure brevity in your answer.  0.33. What is the ratio of the Value added (current US$) in Agriculture in 1965 to that in 1972?
Offer a very short reply. 0.57. What is the ratio of the Value added (current US$) in Industry in 1965 to that in 1973?
Provide a succinct answer. 0.4. What is the ratio of the Value added (current US$) of Manufacturing in 1965 to that in 1973?
Make the answer very short. 0.41. What is the ratio of the Value added (current US$) in Services in 1965 to that in 1973?
Provide a short and direct response. 0.27. What is the ratio of the Value added (current US$) in Agriculture in 1965 to that in 1973?
Offer a very short reply. 0.44. What is the ratio of the Value added (current US$) of Industry in 1966 to that in 1967?
Offer a very short reply. 0.94. What is the ratio of the Value added (current US$) in Manufacturing in 1966 to that in 1967?
Provide a short and direct response. 0.94. What is the ratio of the Value added (current US$) of Services in 1966 to that in 1967?
Provide a short and direct response. 0.82. What is the ratio of the Value added (current US$) in Industry in 1966 to that in 1968?
Offer a very short reply. 0.87. What is the ratio of the Value added (current US$) in Manufacturing in 1966 to that in 1968?
Ensure brevity in your answer.  0.88. What is the ratio of the Value added (current US$) in Services in 1966 to that in 1968?
Your response must be concise. 0.63. What is the ratio of the Value added (current US$) in Agriculture in 1966 to that in 1968?
Keep it short and to the point. 0.88. What is the ratio of the Value added (current US$) of Industry in 1966 to that in 1969?
Make the answer very short. 0.81. What is the ratio of the Value added (current US$) in Manufacturing in 1966 to that in 1969?
Keep it short and to the point. 0.83. What is the ratio of the Value added (current US$) in Services in 1966 to that in 1969?
Give a very brief answer. 0.56. What is the ratio of the Value added (current US$) in Agriculture in 1966 to that in 1969?
Provide a short and direct response. 0.88. What is the ratio of the Value added (current US$) of Industry in 1966 to that in 1970?
Make the answer very short. 0.77. What is the ratio of the Value added (current US$) in Manufacturing in 1966 to that in 1970?
Your response must be concise. 0.79. What is the ratio of the Value added (current US$) in Services in 1966 to that in 1970?
Offer a very short reply. 0.44. What is the ratio of the Value added (current US$) of Agriculture in 1966 to that in 1970?
Ensure brevity in your answer.  0.85. What is the ratio of the Value added (current US$) in Industry in 1966 to that in 1971?
Provide a short and direct response. 0.68. What is the ratio of the Value added (current US$) of Manufacturing in 1966 to that in 1971?
Provide a succinct answer. 0.7. What is the ratio of the Value added (current US$) of Services in 1966 to that in 1971?
Provide a succinct answer. 0.42. What is the ratio of the Value added (current US$) in Agriculture in 1966 to that in 1971?
Provide a succinct answer. 0.83. What is the ratio of the Value added (current US$) in Industry in 1966 to that in 1972?
Make the answer very short. 0.56. What is the ratio of the Value added (current US$) of Manufacturing in 1966 to that in 1972?
Your answer should be very brief. 0.59. What is the ratio of the Value added (current US$) in Services in 1966 to that in 1972?
Keep it short and to the point. 0.37. What is the ratio of the Value added (current US$) of Agriculture in 1966 to that in 1972?
Offer a very short reply. 0.61. What is the ratio of the Value added (current US$) in Industry in 1966 to that in 1973?
Your answer should be very brief. 0.43. What is the ratio of the Value added (current US$) of Manufacturing in 1966 to that in 1973?
Offer a very short reply. 0.45. What is the ratio of the Value added (current US$) of Services in 1966 to that in 1973?
Give a very brief answer. 0.3. What is the ratio of the Value added (current US$) of Agriculture in 1966 to that in 1973?
Make the answer very short. 0.47. What is the ratio of the Value added (current US$) in Industry in 1967 to that in 1968?
Ensure brevity in your answer.  0.93. What is the ratio of the Value added (current US$) of Manufacturing in 1967 to that in 1968?
Provide a succinct answer. 0.94. What is the ratio of the Value added (current US$) of Services in 1967 to that in 1968?
Your answer should be very brief. 0.76. What is the ratio of the Value added (current US$) in Agriculture in 1967 to that in 1968?
Offer a very short reply. 0.95. What is the ratio of the Value added (current US$) of Industry in 1967 to that in 1969?
Offer a terse response. 0.87. What is the ratio of the Value added (current US$) in Manufacturing in 1967 to that in 1969?
Keep it short and to the point. 0.88. What is the ratio of the Value added (current US$) in Services in 1967 to that in 1969?
Offer a very short reply. 0.68. What is the ratio of the Value added (current US$) of Agriculture in 1967 to that in 1969?
Keep it short and to the point. 0.95. What is the ratio of the Value added (current US$) of Industry in 1967 to that in 1970?
Provide a succinct answer. 0.82. What is the ratio of the Value added (current US$) of Manufacturing in 1967 to that in 1970?
Keep it short and to the point. 0.84. What is the ratio of the Value added (current US$) in Services in 1967 to that in 1970?
Provide a short and direct response. 0.53. What is the ratio of the Value added (current US$) in Agriculture in 1967 to that in 1970?
Your answer should be very brief. 0.91. What is the ratio of the Value added (current US$) in Industry in 1967 to that in 1971?
Ensure brevity in your answer.  0.72. What is the ratio of the Value added (current US$) in Manufacturing in 1967 to that in 1971?
Ensure brevity in your answer.  0.74. What is the ratio of the Value added (current US$) of Services in 1967 to that in 1971?
Keep it short and to the point. 0.51. What is the ratio of the Value added (current US$) of Agriculture in 1967 to that in 1971?
Provide a succinct answer. 0.89. What is the ratio of the Value added (current US$) in Industry in 1967 to that in 1972?
Give a very brief answer. 0.6. What is the ratio of the Value added (current US$) in Manufacturing in 1967 to that in 1972?
Provide a succinct answer. 0.63. What is the ratio of the Value added (current US$) in Services in 1967 to that in 1972?
Offer a very short reply. 0.46. What is the ratio of the Value added (current US$) in Agriculture in 1967 to that in 1972?
Give a very brief answer. 0.65. What is the ratio of the Value added (current US$) in Industry in 1967 to that in 1973?
Ensure brevity in your answer.  0.46. What is the ratio of the Value added (current US$) in Manufacturing in 1967 to that in 1973?
Offer a very short reply. 0.47. What is the ratio of the Value added (current US$) of Services in 1967 to that in 1973?
Your answer should be compact. 0.37. What is the ratio of the Value added (current US$) of Agriculture in 1967 to that in 1973?
Give a very brief answer. 0.5. What is the ratio of the Value added (current US$) of Industry in 1968 to that in 1969?
Your response must be concise. 0.93. What is the ratio of the Value added (current US$) in Manufacturing in 1968 to that in 1969?
Provide a short and direct response. 0.94. What is the ratio of the Value added (current US$) of Services in 1968 to that in 1969?
Give a very brief answer. 0.89. What is the ratio of the Value added (current US$) in Industry in 1968 to that in 1970?
Your answer should be very brief. 0.88. What is the ratio of the Value added (current US$) of Manufacturing in 1968 to that in 1970?
Keep it short and to the point. 0.9. What is the ratio of the Value added (current US$) in Services in 1968 to that in 1970?
Provide a short and direct response. 0.7. What is the ratio of the Value added (current US$) in Agriculture in 1968 to that in 1970?
Provide a succinct answer. 0.97. What is the ratio of the Value added (current US$) in Industry in 1968 to that in 1971?
Your answer should be compact. 0.78. What is the ratio of the Value added (current US$) of Manufacturing in 1968 to that in 1971?
Your response must be concise. 0.79. What is the ratio of the Value added (current US$) in Services in 1968 to that in 1971?
Offer a very short reply. 0.67. What is the ratio of the Value added (current US$) of Agriculture in 1968 to that in 1971?
Ensure brevity in your answer.  0.94. What is the ratio of the Value added (current US$) in Industry in 1968 to that in 1972?
Your answer should be compact. 0.65. What is the ratio of the Value added (current US$) in Manufacturing in 1968 to that in 1972?
Give a very brief answer. 0.67. What is the ratio of the Value added (current US$) of Services in 1968 to that in 1972?
Give a very brief answer. 0.6. What is the ratio of the Value added (current US$) in Agriculture in 1968 to that in 1972?
Your answer should be compact. 0.69. What is the ratio of the Value added (current US$) of Industry in 1968 to that in 1973?
Provide a short and direct response. 0.49. What is the ratio of the Value added (current US$) of Manufacturing in 1968 to that in 1973?
Provide a short and direct response. 0.5. What is the ratio of the Value added (current US$) of Services in 1968 to that in 1973?
Your answer should be compact. 0.48. What is the ratio of the Value added (current US$) of Agriculture in 1968 to that in 1973?
Offer a terse response. 0.53. What is the ratio of the Value added (current US$) of Industry in 1969 to that in 1970?
Give a very brief answer. 0.95. What is the ratio of the Value added (current US$) of Manufacturing in 1969 to that in 1970?
Provide a short and direct response. 0.96. What is the ratio of the Value added (current US$) of Services in 1969 to that in 1970?
Your answer should be very brief. 0.78. What is the ratio of the Value added (current US$) of Industry in 1969 to that in 1971?
Keep it short and to the point. 0.83. What is the ratio of the Value added (current US$) of Manufacturing in 1969 to that in 1971?
Offer a terse response. 0.85. What is the ratio of the Value added (current US$) of Services in 1969 to that in 1971?
Give a very brief answer. 0.75. What is the ratio of the Value added (current US$) in Agriculture in 1969 to that in 1971?
Make the answer very short. 0.94. What is the ratio of the Value added (current US$) in Industry in 1969 to that in 1972?
Provide a succinct answer. 0.7. What is the ratio of the Value added (current US$) of Manufacturing in 1969 to that in 1972?
Offer a terse response. 0.71. What is the ratio of the Value added (current US$) of Services in 1969 to that in 1972?
Offer a very short reply. 0.67. What is the ratio of the Value added (current US$) of Agriculture in 1969 to that in 1972?
Offer a very short reply. 0.69. What is the ratio of the Value added (current US$) in Industry in 1969 to that in 1973?
Give a very brief answer. 0.53. What is the ratio of the Value added (current US$) of Manufacturing in 1969 to that in 1973?
Keep it short and to the point. 0.54. What is the ratio of the Value added (current US$) of Services in 1969 to that in 1973?
Provide a short and direct response. 0.54. What is the ratio of the Value added (current US$) of Agriculture in 1969 to that in 1973?
Ensure brevity in your answer.  0.53. What is the ratio of the Value added (current US$) in Industry in 1970 to that in 1971?
Offer a terse response. 0.88. What is the ratio of the Value added (current US$) of Manufacturing in 1970 to that in 1971?
Make the answer very short. 0.88. What is the ratio of the Value added (current US$) of Services in 1970 to that in 1971?
Provide a succinct answer. 0.96. What is the ratio of the Value added (current US$) of Agriculture in 1970 to that in 1971?
Your response must be concise. 0.98. What is the ratio of the Value added (current US$) of Industry in 1970 to that in 1972?
Your response must be concise. 0.73. What is the ratio of the Value added (current US$) of Manufacturing in 1970 to that in 1972?
Ensure brevity in your answer.  0.75. What is the ratio of the Value added (current US$) in Services in 1970 to that in 1972?
Ensure brevity in your answer.  0.86. What is the ratio of the Value added (current US$) in Agriculture in 1970 to that in 1972?
Give a very brief answer. 0.71. What is the ratio of the Value added (current US$) in Industry in 1970 to that in 1973?
Give a very brief answer. 0.56. What is the ratio of the Value added (current US$) in Manufacturing in 1970 to that in 1973?
Provide a succinct answer. 0.56. What is the ratio of the Value added (current US$) of Services in 1970 to that in 1973?
Make the answer very short. 0.7. What is the ratio of the Value added (current US$) of Agriculture in 1970 to that in 1973?
Keep it short and to the point. 0.55. What is the ratio of the Value added (current US$) of Industry in 1971 to that in 1972?
Offer a very short reply. 0.83. What is the ratio of the Value added (current US$) of Manufacturing in 1971 to that in 1972?
Keep it short and to the point. 0.84. What is the ratio of the Value added (current US$) in Services in 1971 to that in 1972?
Give a very brief answer. 0.89. What is the ratio of the Value added (current US$) in Agriculture in 1971 to that in 1972?
Provide a short and direct response. 0.73. What is the ratio of the Value added (current US$) of Industry in 1971 to that in 1973?
Your answer should be compact. 0.64. What is the ratio of the Value added (current US$) in Manufacturing in 1971 to that in 1973?
Your answer should be compact. 0.64. What is the ratio of the Value added (current US$) in Services in 1971 to that in 1973?
Keep it short and to the point. 0.72. What is the ratio of the Value added (current US$) of Agriculture in 1971 to that in 1973?
Offer a very short reply. 0.56. What is the ratio of the Value added (current US$) of Industry in 1972 to that in 1973?
Provide a short and direct response. 0.76. What is the ratio of the Value added (current US$) of Manufacturing in 1972 to that in 1973?
Provide a short and direct response. 0.75. What is the ratio of the Value added (current US$) of Services in 1972 to that in 1973?
Offer a very short reply. 0.81. What is the ratio of the Value added (current US$) in Agriculture in 1972 to that in 1973?
Provide a short and direct response. 0.77. What is the difference between the highest and the second highest Value added (current US$) of Industry?
Offer a very short reply. 1.82e+1. What is the difference between the highest and the second highest Value added (current US$) in Manufacturing?
Your answer should be compact. 1.28e+1. What is the difference between the highest and the second highest Value added (current US$) of Services?
Your answer should be compact. 5.49e+1. What is the difference between the highest and the second highest Value added (current US$) in Agriculture?
Offer a terse response. 4.15e+09. What is the difference between the highest and the lowest Value added (current US$) of Industry?
Give a very brief answer. 4.60e+1. What is the difference between the highest and the lowest Value added (current US$) of Manufacturing?
Provide a succinct answer. 3.06e+1. What is the difference between the highest and the lowest Value added (current US$) in Services?
Give a very brief answer. 2.13e+11. What is the difference between the highest and the lowest Value added (current US$) in Agriculture?
Provide a short and direct response. 1.01e+1. 